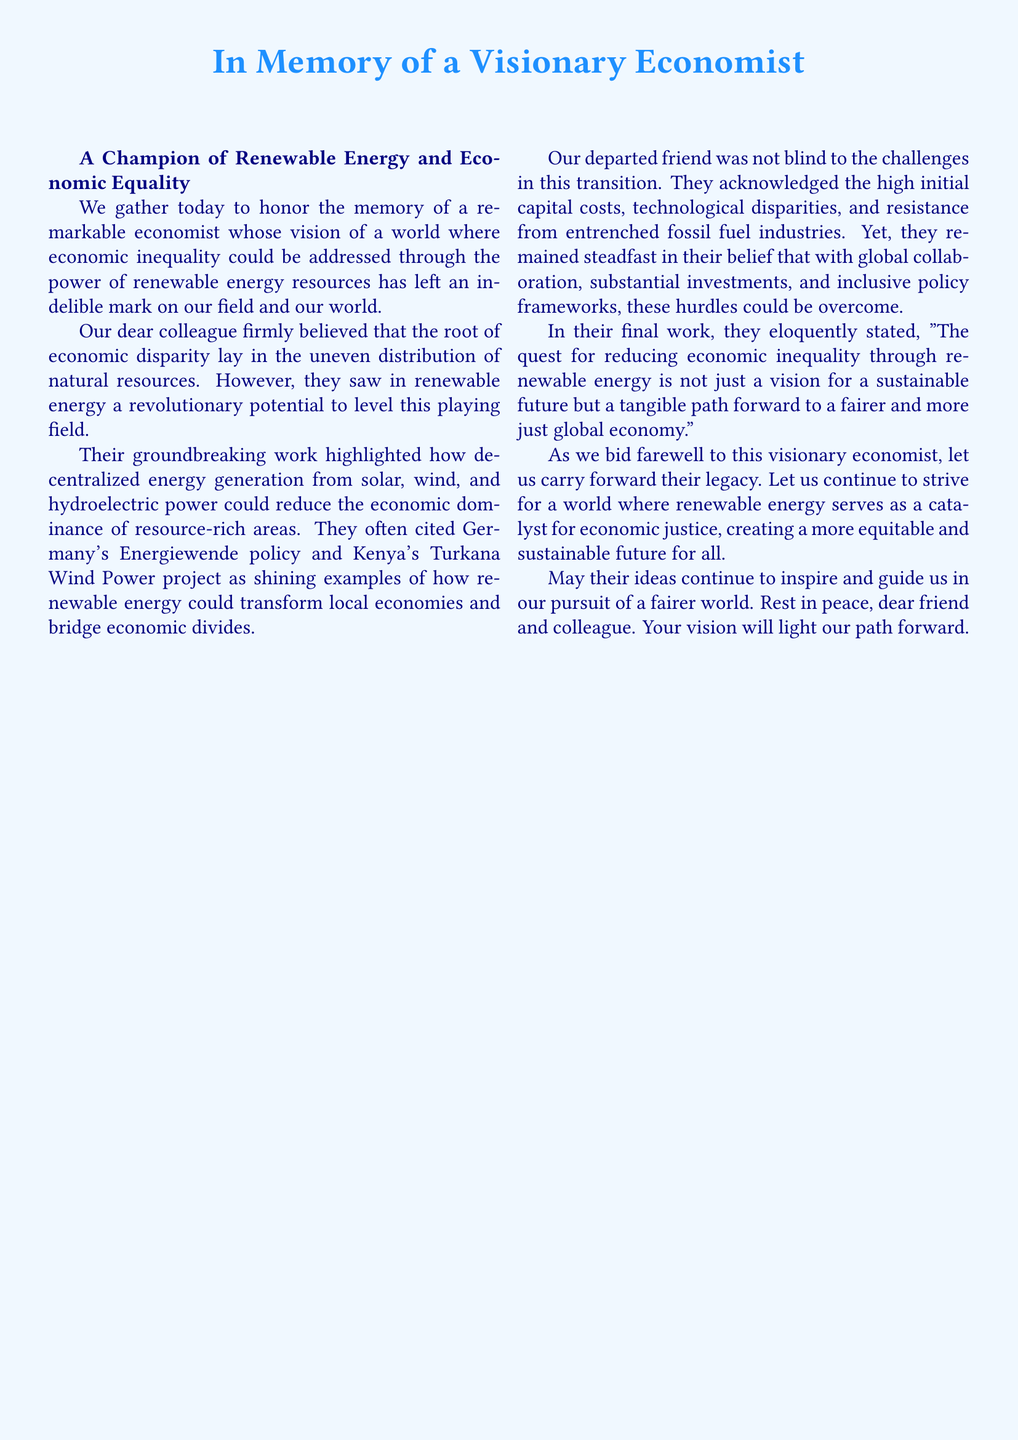what is the title of the document? The title is prominently displayed at the beginning of the document.
Answer: In Memory of a Visionary Economist who is the primary focus of the eulogy? The eulogy centers around a remarkable economist whose contributions are celebrated.
Answer: a remarkable economist which two countries are cited as examples in the document? The document references specific countries that illustrate the potential of renewable energy.
Answer: Germany and Kenya what is a significant challenge mentioned in the document regarding the transition to renewable energy? The document lists multiple challenges, but one key difficulty is highlighted.
Answer: high initial capital costs what quote is included in the economist's final work? The document contains a notable quote reflecting the economist's beliefs.
Answer: The quest for reducing economic inequality through renewable energy is not just a vision for a sustainable future but a tangible path forward to a fairer and more just global economy what is the main belief of the economist regarding economic inequality? The economist’s fundamental belief regarding the cause of economic inequality is outlined.
Answer: uneven distribution of natural resources what does the document suggest as a necessary condition for overcoming challenges in renewable energy? The document emphasizes the importance of collaborative efforts to address challenges.
Answer: global collaboration how does the eulogy conclude? The closing sentiments of the eulogy reflect on the legacy of the economist and future aspirations.
Answer: Rest in peace, dear friend and colleague 